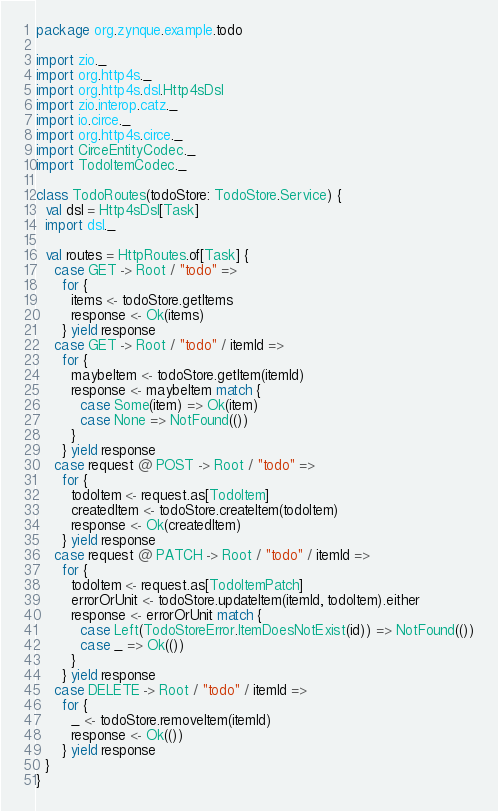<code> <loc_0><loc_0><loc_500><loc_500><_Scala_>package org.zynque.example.todo

import zio._
import org.http4s._
import org.http4s.dsl.Http4sDsl
import zio.interop.catz._
import io.circe._
import org.http4s.circe._
import CirceEntityCodec._
import TodoItemCodec._

class TodoRoutes(todoStore: TodoStore.Service) {
  val dsl = Http4sDsl[Task]
  import dsl._

  val routes = HttpRoutes.of[Task] {
    case GET -> Root / "todo" =>
      for {
        items <- todoStore.getItems
        response <- Ok(items)
      } yield response
    case GET -> Root / "todo" / itemId =>
      for {
        maybeItem <- todoStore.getItem(itemId)
        response <- maybeItem match {
          case Some(item) => Ok(item)
          case None => NotFound(())
        }
      } yield response
    case request @ POST -> Root / "todo" =>
      for {
        todoItem <- request.as[TodoItem]
        createdItem <- todoStore.createItem(todoItem)
        response <- Ok(createdItem)
      } yield response
    case request @ PATCH -> Root / "todo" / itemId =>
      for {
        todoItem <- request.as[TodoItemPatch]
        errorOrUnit <- todoStore.updateItem(itemId, todoItem).either
        response <- errorOrUnit match {
          case Left(TodoStoreError.ItemDoesNotExist(id)) => NotFound(())
          case _ => Ok(())
        }
      } yield response
    case DELETE -> Root / "todo" / itemId =>
      for {
        _ <- todoStore.removeItem(itemId)
        response <- Ok(())
      } yield response
  }
}
</code> 